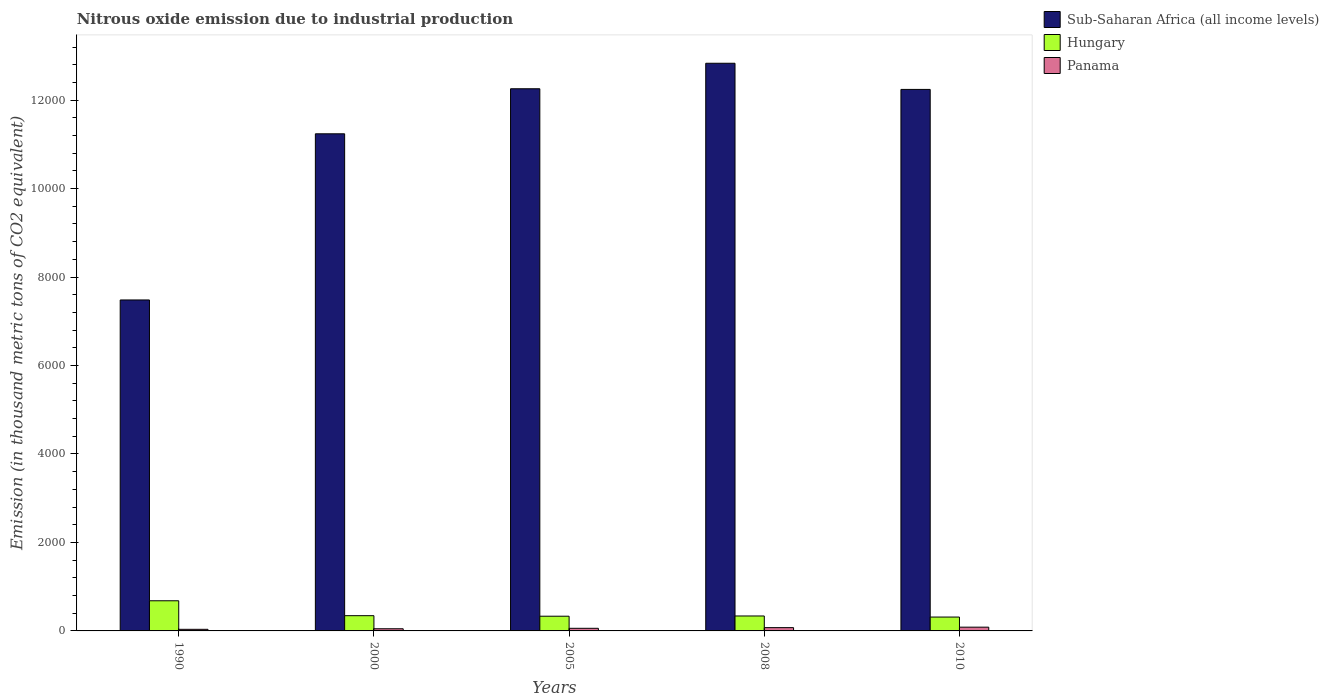How many groups of bars are there?
Offer a terse response. 5. Are the number of bars on each tick of the X-axis equal?
Your answer should be compact. Yes. In how many cases, is the number of bars for a given year not equal to the number of legend labels?
Offer a very short reply. 0. What is the amount of nitrous oxide emitted in Hungary in 1990?
Your answer should be very brief. 681.7. Across all years, what is the maximum amount of nitrous oxide emitted in Hungary?
Give a very brief answer. 681.7. Across all years, what is the minimum amount of nitrous oxide emitted in Panama?
Keep it short and to the point. 36.2. In which year was the amount of nitrous oxide emitted in Panama maximum?
Offer a terse response. 2010. What is the total amount of nitrous oxide emitted in Sub-Saharan Africa (all income levels) in the graph?
Your answer should be very brief. 5.61e+04. What is the difference between the amount of nitrous oxide emitted in Hungary in 1990 and that in 2005?
Provide a short and direct response. 349.1. What is the difference between the amount of nitrous oxide emitted in Panama in 2008 and the amount of nitrous oxide emitted in Hungary in 1990?
Offer a terse response. -607.4. What is the average amount of nitrous oxide emitted in Panama per year?
Your response must be concise. 60.68. In the year 2005, what is the difference between the amount of nitrous oxide emitted in Panama and amount of nitrous oxide emitted in Sub-Saharan Africa (all income levels)?
Keep it short and to the point. -1.22e+04. What is the ratio of the amount of nitrous oxide emitted in Hungary in 1990 to that in 2008?
Provide a succinct answer. 2.02. Is the amount of nitrous oxide emitted in Panama in 2000 less than that in 2005?
Your answer should be compact. Yes. What is the difference between the highest and the second highest amount of nitrous oxide emitted in Hungary?
Your answer should be very brief. 337.2. What is the difference between the highest and the lowest amount of nitrous oxide emitted in Panama?
Give a very brief answer. 48.9. In how many years, is the amount of nitrous oxide emitted in Sub-Saharan Africa (all income levels) greater than the average amount of nitrous oxide emitted in Sub-Saharan Africa (all income levels) taken over all years?
Your response must be concise. 4. Is the sum of the amount of nitrous oxide emitted in Hungary in 2000 and 2005 greater than the maximum amount of nitrous oxide emitted in Sub-Saharan Africa (all income levels) across all years?
Your response must be concise. No. What does the 3rd bar from the left in 2005 represents?
Give a very brief answer. Panama. What does the 2nd bar from the right in 2010 represents?
Provide a short and direct response. Hungary. How many years are there in the graph?
Offer a very short reply. 5. What is the difference between two consecutive major ticks on the Y-axis?
Keep it short and to the point. 2000. Does the graph contain any zero values?
Your answer should be very brief. No. What is the title of the graph?
Your response must be concise. Nitrous oxide emission due to industrial production. What is the label or title of the Y-axis?
Keep it short and to the point. Emission (in thousand metric tons of CO2 equivalent). What is the Emission (in thousand metric tons of CO2 equivalent) in Sub-Saharan Africa (all income levels) in 1990?
Provide a succinct answer. 7482.3. What is the Emission (in thousand metric tons of CO2 equivalent) of Hungary in 1990?
Provide a short and direct response. 681.7. What is the Emission (in thousand metric tons of CO2 equivalent) of Panama in 1990?
Make the answer very short. 36.2. What is the Emission (in thousand metric tons of CO2 equivalent) of Sub-Saharan Africa (all income levels) in 2000?
Your answer should be very brief. 1.12e+04. What is the Emission (in thousand metric tons of CO2 equivalent) in Hungary in 2000?
Give a very brief answer. 344.5. What is the Emission (in thousand metric tons of CO2 equivalent) of Panama in 2000?
Your answer should be very brief. 48.8. What is the Emission (in thousand metric tons of CO2 equivalent) in Sub-Saharan Africa (all income levels) in 2005?
Ensure brevity in your answer.  1.23e+04. What is the Emission (in thousand metric tons of CO2 equivalent) of Hungary in 2005?
Keep it short and to the point. 332.6. What is the Emission (in thousand metric tons of CO2 equivalent) in Panama in 2005?
Offer a very short reply. 59. What is the Emission (in thousand metric tons of CO2 equivalent) in Sub-Saharan Africa (all income levels) in 2008?
Keep it short and to the point. 1.28e+04. What is the Emission (in thousand metric tons of CO2 equivalent) in Hungary in 2008?
Provide a succinct answer. 337.9. What is the Emission (in thousand metric tons of CO2 equivalent) of Panama in 2008?
Ensure brevity in your answer.  74.3. What is the Emission (in thousand metric tons of CO2 equivalent) of Sub-Saharan Africa (all income levels) in 2010?
Provide a succinct answer. 1.22e+04. What is the Emission (in thousand metric tons of CO2 equivalent) in Hungary in 2010?
Ensure brevity in your answer.  313.6. What is the Emission (in thousand metric tons of CO2 equivalent) of Panama in 2010?
Offer a terse response. 85.1. Across all years, what is the maximum Emission (in thousand metric tons of CO2 equivalent) in Sub-Saharan Africa (all income levels)?
Ensure brevity in your answer.  1.28e+04. Across all years, what is the maximum Emission (in thousand metric tons of CO2 equivalent) in Hungary?
Your answer should be very brief. 681.7. Across all years, what is the maximum Emission (in thousand metric tons of CO2 equivalent) of Panama?
Provide a short and direct response. 85.1. Across all years, what is the minimum Emission (in thousand metric tons of CO2 equivalent) of Sub-Saharan Africa (all income levels)?
Provide a succinct answer. 7482.3. Across all years, what is the minimum Emission (in thousand metric tons of CO2 equivalent) of Hungary?
Your response must be concise. 313.6. Across all years, what is the minimum Emission (in thousand metric tons of CO2 equivalent) in Panama?
Your response must be concise. 36.2. What is the total Emission (in thousand metric tons of CO2 equivalent) of Sub-Saharan Africa (all income levels) in the graph?
Keep it short and to the point. 5.61e+04. What is the total Emission (in thousand metric tons of CO2 equivalent) in Hungary in the graph?
Offer a very short reply. 2010.3. What is the total Emission (in thousand metric tons of CO2 equivalent) in Panama in the graph?
Give a very brief answer. 303.4. What is the difference between the Emission (in thousand metric tons of CO2 equivalent) of Sub-Saharan Africa (all income levels) in 1990 and that in 2000?
Ensure brevity in your answer.  -3756.4. What is the difference between the Emission (in thousand metric tons of CO2 equivalent) in Hungary in 1990 and that in 2000?
Keep it short and to the point. 337.2. What is the difference between the Emission (in thousand metric tons of CO2 equivalent) in Sub-Saharan Africa (all income levels) in 1990 and that in 2005?
Keep it short and to the point. -4774.5. What is the difference between the Emission (in thousand metric tons of CO2 equivalent) of Hungary in 1990 and that in 2005?
Make the answer very short. 349.1. What is the difference between the Emission (in thousand metric tons of CO2 equivalent) of Panama in 1990 and that in 2005?
Offer a very short reply. -22.8. What is the difference between the Emission (in thousand metric tons of CO2 equivalent) of Sub-Saharan Africa (all income levels) in 1990 and that in 2008?
Give a very brief answer. -5351.1. What is the difference between the Emission (in thousand metric tons of CO2 equivalent) in Hungary in 1990 and that in 2008?
Provide a succinct answer. 343.8. What is the difference between the Emission (in thousand metric tons of CO2 equivalent) of Panama in 1990 and that in 2008?
Your response must be concise. -38.1. What is the difference between the Emission (in thousand metric tons of CO2 equivalent) in Sub-Saharan Africa (all income levels) in 1990 and that in 2010?
Ensure brevity in your answer.  -4759.9. What is the difference between the Emission (in thousand metric tons of CO2 equivalent) of Hungary in 1990 and that in 2010?
Your response must be concise. 368.1. What is the difference between the Emission (in thousand metric tons of CO2 equivalent) of Panama in 1990 and that in 2010?
Ensure brevity in your answer.  -48.9. What is the difference between the Emission (in thousand metric tons of CO2 equivalent) of Sub-Saharan Africa (all income levels) in 2000 and that in 2005?
Make the answer very short. -1018.1. What is the difference between the Emission (in thousand metric tons of CO2 equivalent) in Hungary in 2000 and that in 2005?
Offer a terse response. 11.9. What is the difference between the Emission (in thousand metric tons of CO2 equivalent) of Panama in 2000 and that in 2005?
Provide a succinct answer. -10.2. What is the difference between the Emission (in thousand metric tons of CO2 equivalent) of Sub-Saharan Africa (all income levels) in 2000 and that in 2008?
Provide a short and direct response. -1594.7. What is the difference between the Emission (in thousand metric tons of CO2 equivalent) of Panama in 2000 and that in 2008?
Make the answer very short. -25.5. What is the difference between the Emission (in thousand metric tons of CO2 equivalent) of Sub-Saharan Africa (all income levels) in 2000 and that in 2010?
Provide a short and direct response. -1003.5. What is the difference between the Emission (in thousand metric tons of CO2 equivalent) of Hungary in 2000 and that in 2010?
Your answer should be compact. 30.9. What is the difference between the Emission (in thousand metric tons of CO2 equivalent) of Panama in 2000 and that in 2010?
Your answer should be compact. -36.3. What is the difference between the Emission (in thousand metric tons of CO2 equivalent) of Sub-Saharan Africa (all income levels) in 2005 and that in 2008?
Keep it short and to the point. -576.6. What is the difference between the Emission (in thousand metric tons of CO2 equivalent) in Panama in 2005 and that in 2008?
Offer a terse response. -15.3. What is the difference between the Emission (in thousand metric tons of CO2 equivalent) of Panama in 2005 and that in 2010?
Offer a terse response. -26.1. What is the difference between the Emission (in thousand metric tons of CO2 equivalent) in Sub-Saharan Africa (all income levels) in 2008 and that in 2010?
Keep it short and to the point. 591.2. What is the difference between the Emission (in thousand metric tons of CO2 equivalent) in Hungary in 2008 and that in 2010?
Give a very brief answer. 24.3. What is the difference between the Emission (in thousand metric tons of CO2 equivalent) of Panama in 2008 and that in 2010?
Your answer should be very brief. -10.8. What is the difference between the Emission (in thousand metric tons of CO2 equivalent) in Sub-Saharan Africa (all income levels) in 1990 and the Emission (in thousand metric tons of CO2 equivalent) in Hungary in 2000?
Make the answer very short. 7137.8. What is the difference between the Emission (in thousand metric tons of CO2 equivalent) of Sub-Saharan Africa (all income levels) in 1990 and the Emission (in thousand metric tons of CO2 equivalent) of Panama in 2000?
Provide a short and direct response. 7433.5. What is the difference between the Emission (in thousand metric tons of CO2 equivalent) of Hungary in 1990 and the Emission (in thousand metric tons of CO2 equivalent) of Panama in 2000?
Your answer should be very brief. 632.9. What is the difference between the Emission (in thousand metric tons of CO2 equivalent) of Sub-Saharan Africa (all income levels) in 1990 and the Emission (in thousand metric tons of CO2 equivalent) of Hungary in 2005?
Give a very brief answer. 7149.7. What is the difference between the Emission (in thousand metric tons of CO2 equivalent) of Sub-Saharan Africa (all income levels) in 1990 and the Emission (in thousand metric tons of CO2 equivalent) of Panama in 2005?
Your response must be concise. 7423.3. What is the difference between the Emission (in thousand metric tons of CO2 equivalent) of Hungary in 1990 and the Emission (in thousand metric tons of CO2 equivalent) of Panama in 2005?
Offer a very short reply. 622.7. What is the difference between the Emission (in thousand metric tons of CO2 equivalent) in Sub-Saharan Africa (all income levels) in 1990 and the Emission (in thousand metric tons of CO2 equivalent) in Hungary in 2008?
Provide a short and direct response. 7144.4. What is the difference between the Emission (in thousand metric tons of CO2 equivalent) of Sub-Saharan Africa (all income levels) in 1990 and the Emission (in thousand metric tons of CO2 equivalent) of Panama in 2008?
Your response must be concise. 7408. What is the difference between the Emission (in thousand metric tons of CO2 equivalent) of Hungary in 1990 and the Emission (in thousand metric tons of CO2 equivalent) of Panama in 2008?
Your answer should be compact. 607.4. What is the difference between the Emission (in thousand metric tons of CO2 equivalent) in Sub-Saharan Africa (all income levels) in 1990 and the Emission (in thousand metric tons of CO2 equivalent) in Hungary in 2010?
Give a very brief answer. 7168.7. What is the difference between the Emission (in thousand metric tons of CO2 equivalent) of Sub-Saharan Africa (all income levels) in 1990 and the Emission (in thousand metric tons of CO2 equivalent) of Panama in 2010?
Your answer should be compact. 7397.2. What is the difference between the Emission (in thousand metric tons of CO2 equivalent) in Hungary in 1990 and the Emission (in thousand metric tons of CO2 equivalent) in Panama in 2010?
Give a very brief answer. 596.6. What is the difference between the Emission (in thousand metric tons of CO2 equivalent) of Sub-Saharan Africa (all income levels) in 2000 and the Emission (in thousand metric tons of CO2 equivalent) of Hungary in 2005?
Provide a short and direct response. 1.09e+04. What is the difference between the Emission (in thousand metric tons of CO2 equivalent) in Sub-Saharan Africa (all income levels) in 2000 and the Emission (in thousand metric tons of CO2 equivalent) in Panama in 2005?
Your answer should be very brief. 1.12e+04. What is the difference between the Emission (in thousand metric tons of CO2 equivalent) of Hungary in 2000 and the Emission (in thousand metric tons of CO2 equivalent) of Panama in 2005?
Your response must be concise. 285.5. What is the difference between the Emission (in thousand metric tons of CO2 equivalent) in Sub-Saharan Africa (all income levels) in 2000 and the Emission (in thousand metric tons of CO2 equivalent) in Hungary in 2008?
Your answer should be compact. 1.09e+04. What is the difference between the Emission (in thousand metric tons of CO2 equivalent) of Sub-Saharan Africa (all income levels) in 2000 and the Emission (in thousand metric tons of CO2 equivalent) of Panama in 2008?
Your response must be concise. 1.12e+04. What is the difference between the Emission (in thousand metric tons of CO2 equivalent) of Hungary in 2000 and the Emission (in thousand metric tons of CO2 equivalent) of Panama in 2008?
Keep it short and to the point. 270.2. What is the difference between the Emission (in thousand metric tons of CO2 equivalent) of Sub-Saharan Africa (all income levels) in 2000 and the Emission (in thousand metric tons of CO2 equivalent) of Hungary in 2010?
Give a very brief answer. 1.09e+04. What is the difference between the Emission (in thousand metric tons of CO2 equivalent) in Sub-Saharan Africa (all income levels) in 2000 and the Emission (in thousand metric tons of CO2 equivalent) in Panama in 2010?
Give a very brief answer. 1.12e+04. What is the difference between the Emission (in thousand metric tons of CO2 equivalent) of Hungary in 2000 and the Emission (in thousand metric tons of CO2 equivalent) of Panama in 2010?
Your response must be concise. 259.4. What is the difference between the Emission (in thousand metric tons of CO2 equivalent) of Sub-Saharan Africa (all income levels) in 2005 and the Emission (in thousand metric tons of CO2 equivalent) of Hungary in 2008?
Provide a short and direct response. 1.19e+04. What is the difference between the Emission (in thousand metric tons of CO2 equivalent) in Sub-Saharan Africa (all income levels) in 2005 and the Emission (in thousand metric tons of CO2 equivalent) in Panama in 2008?
Offer a terse response. 1.22e+04. What is the difference between the Emission (in thousand metric tons of CO2 equivalent) of Hungary in 2005 and the Emission (in thousand metric tons of CO2 equivalent) of Panama in 2008?
Your answer should be compact. 258.3. What is the difference between the Emission (in thousand metric tons of CO2 equivalent) of Sub-Saharan Africa (all income levels) in 2005 and the Emission (in thousand metric tons of CO2 equivalent) of Hungary in 2010?
Give a very brief answer. 1.19e+04. What is the difference between the Emission (in thousand metric tons of CO2 equivalent) in Sub-Saharan Africa (all income levels) in 2005 and the Emission (in thousand metric tons of CO2 equivalent) in Panama in 2010?
Your response must be concise. 1.22e+04. What is the difference between the Emission (in thousand metric tons of CO2 equivalent) in Hungary in 2005 and the Emission (in thousand metric tons of CO2 equivalent) in Panama in 2010?
Your response must be concise. 247.5. What is the difference between the Emission (in thousand metric tons of CO2 equivalent) in Sub-Saharan Africa (all income levels) in 2008 and the Emission (in thousand metric tons of CO2 equivalent) in Hungary in 2010?
Your answer should be very brief. 1.25e+04. What is the difference between the Emission (in thousand metric tons of CO2 equivalent) of Sub-Saharan Africa (all income levels) in 2008 and the Emission (in thousand metric tons of CO2 equivalent) of Panama in 2010?
Provide a succinct answer. 1.27e+04. What is the difference between the Emission (in thousand metric tons of CO2 equivalent) in Hungary in 2008 and the Emission (in thousand metric tons of CO2 equivalent) in Panama in 2010?
Give a very brief answer. 252.8. What is the average Emission (in thousand metric tons of CO2 equivalent) of Sub-Saharan Africa (all income levels) per year?
Your response must be concise. 1.12e+04. What is the average Emission (in thousand metric tons of CO2 equivalent) of Hungary per year?
Your answer should be compact. 402.06. What is the average Emission (in thousand metric tons of CO2 equivalent) of Panama per year?
Offer a terse response. 60.68. In the year 1990, what is the difference between the Emission (in thousand metric tons of CO2 equivalent) of Sub-Saharan Africa (all income levels) and Emission (in thousand metric tons of CO2 equivalent) of Hungary?
Your response must be concise. 6800.6. In the year 1990, what is the difference between the Emission (in thousand metric tons of CO2 equivalent) in Sub-Saharan Africa (all income levels) and Emission (in thousand metric tons of CO2 equivalent) in Panama?
Your response must be concise. 7446.1. In the year 1990, what is the difference between the Emission (in thousand metric tons of CO2 equivalent) of Hungary and Emission (in thousand metric tons of CO2 equivalent) of Panama?
Provide a succinct answer. 645.5. In the year 2000, what is the difference between the Emission (in thousand metric tons of CO2 equivalent) of Sub-Saharan Africa (all income levels) and Emission (in thousand metric tons of CO2 equivalent) of Hungary?
Your answer should be compact. 1.09e+04. In the year 2000, what is the difference between the Emission (in thousand metric tons of CO2 equivalent) of Sub-Saharan Africa (all income levels) and Emission (in thousand metric tons of CO2 equivalent) of Panama?
Your response must be concise. 1.12e+04. In the year 2000, what is the difference between the Emission (in thousand metric tons of CO2 equivalent) of Hungary and Emission (in thousand metric tons of CO2 equivalent) of Panama?
Your response must be concise. 295.7. In the year 2005, what is the difference between the Emission (in thousand metric tons of CO2 equivalent) of Sub-Saharan Africa (all income levels) and Emission (in thousand metric tons of CO2 equivalent) of Hungary?
Ensure brevity in your answer.  1.19e+04. In the year 2005, what is the difference between the Emission (in thousand metric tons of CO2 equivalent) of Sub-Saharan Africa (all income levels) and Emission (in thousand metric tons of CO2 equivalent) of Panama?
Your response must be concise. 1.22e+04. In the year 2005, what is the difference between the Emission (in thousand metric tons of CO2 equivalent) of Hungary and Emission (in thousand metric tons of CO2 equivalent) of Panama?
Provide a succinct answer. 273.6. In the year 2008, what is the difference between the Emission (in thousand metric tons of CO2 equivalent) in Sub-Saharan Africa (all income levels) and Emission (in thousand metric tons of CO2 equivalent) in Hungary?
Your response must be concise. 1.25e+04. In the year 2008, what is the difference between the Emission (in thousand metric tons of CO2 equivalent) of Sub-Saharan Africa (all income levels) and Emission (in thousand metric tons of CO2 equivalent) of Panama?
Ensure brevity in your answer.  1.28e+04. In the year 2008, what is the difference between the Emission (in thousand metric tons of CO2 equivalent) of Hungary and Emission (in thousand metric tons of CO2 equivalent) of Panama?
Offer a terse response. 263.6. In the year 2010, what is the difference between the Emission (in thousand metric tons of CO2 equivalent) in Sub-Saharan Africa (all income levels) and Emission (in thousand metric tons of CO2 equivalent) in Hungary?
Your response must be concise. 1.19e+04. In the year 2010, what is the difference between the Emission (in thousand metric tons of CO2 equivalent) of Sub-Saharan Africa (all income levels) and Emission (in thousand metric tons of CO2 equivalent) of Panama?
Give a very brief answer. 1.22e+04. In the year 2010, what is the difference between the Emission (in thousand metric tons of CO2 equivalent) of Hungary and Emission (in thousand metric tons of CO2 equivalent) of Panama?
Provide a short and direct response. 228.5. What is the ratio of the Emission (in thousand metric tons of CO2 equivalent) in Sub-Saharan Africa (all income levels) in 1990 to that in 2000?
Keep it short and to the point. 0.67. What is the ratio of the Emission (in thousand metric tons of CO2 equivalent) of Hungary in 1990 to that in 2000?
Keep it short and to the point. 1.98. What is the ratio of the Emission (in thousand metric tons of CO2 equivalent) of Panama in 1990 to that in 2000?
Give a very brief answer. 0.74. What is the ratio of the Emission (in thousand metric tons of CO2 equivalent) in Sub-Saharan Africa (all income levels) in 1990 to that in 2005?
Offer a terse response. 0.61. What is the ratio of the Emission (in thousand metric tons of CO2 equivalent) of Hungary in 1990 to that in 2005?
Your answer should be very brief. 2.05. What is the ratio of the Emission (in thousand metric tons of CO2 equivalent) of Panama in 1990 to that in 2005?
Offer a terse response. 0.61. What is the ratio of the Emission (in thousand metric tons of CO2 equivalent) in Sub-Saharan Africa (all income levels) in 1990 to that in 2008?
Your answer should be compact. 0.58. What is the ratio of the Emission (in thousand metric tons of CO2 equivalent) of Hungary in 1990 to that in 2008?
Offer a terse response. 2.02. What is the ratio of the Emission (in thousand metric tons of CO2 equivalent) in Panama in 1990 to that in 2008?
Offer a very short reply. 0.49. What is the ratio of the Emission (in thousand metric tons of CO2 equivalent) in Sub-Saharan Africa (all income levels) in 1990 to that in 2010?
Give a very brief answer. 0.61. What is the ratio of the Emission (in thousand metric tons of CO2 equivalent) of Hungary in 1990 to that in 2010?
Make the answer very short. 2.17. What is the ratio of the Emission (in thousand metric tons of CO2 equivalent) in Panama in 1990 to that in 2010?
Offer a terse response. 0.43. What is the ratio of the Emission (in thousand metric tons of CO2 equivalent) in Sub-Saharan Africa (all income levels) in 2000 to that in 2005?
Keep it short and to the point. 0.92. What is the ratio of the Emission (in thousand metric tons of CO2 equivalent) of Hungary in 2000 to that in 2005?
Your answer should be very brief. 1.04. What is the ratio of the Emission (in thousand metric tons of CO2 equivalent) in Panama in 2000 to that in 2005?
Your answer should be compact. 0.83. What is the ratio of the Emission (in thousand metric tons of CO2 equivalent) of Sub-Saharan Africa (all income levels) in 2000 to that in 2008?
Ensure brevity in your answer.  0.88. What is the ratio of the Emission (in thousand metric tons of CO2 equivalent) in Hungary in 2000 to that in 2008?
Ensure brevity in your answer.  1.02. What is the ratio of the Emission (in thousand metric tons of CO2 equivalent) of Panama in 2000 to that in 2008?
Provide a succinct answer. 0.66. What is the ratio of the Emission (in thousand metric tons of CO2 equivalent) of Sub-Saharan Africa (all income levels) in 2000 to that in 2010?
Offer a very short reply. 0.92. What is the ratio of the Emission (in thousand metric tons of CO2 equivalent) in Hungary in 2000 to that in 2010?
Provide a succinct answer. 1.1. What is the ratio of the Emission (in thousand metric tons of CO2 equivalent) of Panama in 2000 to that in 2010?
Make the answer very short. 0.57. What is the ratio of the Emission (in thousand metric tons of CO2 equivalent) of Sub-Saharan Africa (all income levels) in 2005 to that in 2008?
Provide a short and direct response. 0.96. What is the ratio of the Emission (in thousand metric tons of CO2 equivalent) in Hungary in 2005 to that in 2008?
Your answer should be very brief. 0.98. What is the ratio of the Emission (in thousand metric tons of CO2 equivalent) in Panama in 2005 to that in 2008?
Provide a succinct answer. 0.79. What is the ratio of the Emission (in thousand metric tons of CO2 equivalent) in Hungary in 2005 to that in 2010?
Your answer should be very brief. 1.06. What is the ratio of the Emission (in thousand metric tons of CO2 equivalent) of Panama in 2005 to that in 2010?
Provide a short and direct response. 0.69. What is the ratio of the Emission (in thousand metric tons of CO2 equivalent) in Sub-Saharan Africa (all income levels) in 2008 to that in 2010?
Make the answer very short. 1.05. What is the ratio of the Emission (in thousand metric tons of CO2 equivalent) in Hungary in 2008 to that in 2010?
Make the answer very short. 1.08. What is the ratio of the Emission (in thousand metric tons of CO2 equivalent) of Panama in 2008 to that in 2010?
Keep it short and to the point. 0.87. What is the difference between the highest and the second highest Emission (in thousand metric tons of CO2 equivalent) of Sub-Saharan Africa (all income levels)?
Your answer should be compact. 576.6. What is the difference between the highest and the second highest Emission (in thousand metric tons of CO2 equivalent) in Hungary?
Your answer should be compact. 337.2. What is the difference between the highest and the second highest Emission (in thousand metric tons of CO2 equivalent) of Panama?
Offer a very short reply. 10.8. What is the difference between the highest and the lowest Emission (in thousand metric tons of CO2 equivalent) of Sub-Saharan Africa (all income levels)?
Make the answer very short. 5351.1. What is the difference between the highest and the lowest Emission (in thousand metric tons of CO2 equivalent) in Hungary?
Your answer should be very brief. 368.1. What is the difference between the highest and the lowest Emission (in thousand metric tons of CO2 equivalent) of Panama?
Provide a short and direct response. 48.9. 